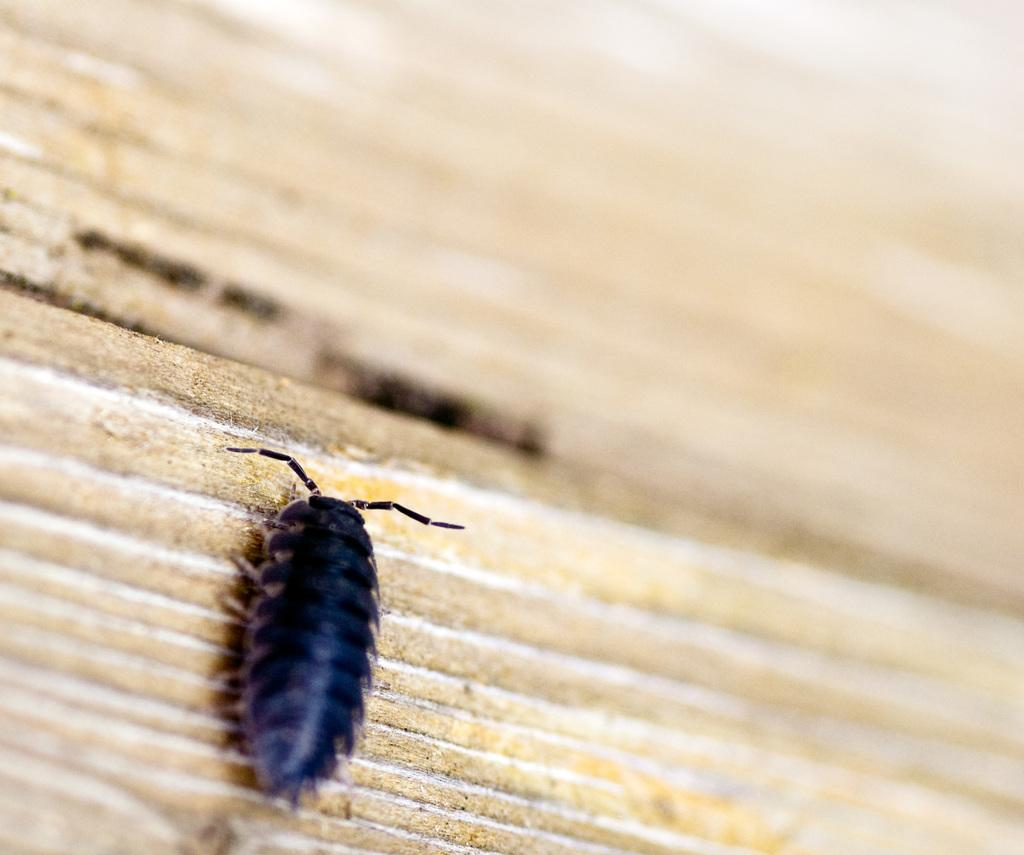What type of creature can be seen in the image? There is an insect in the image. Where is the insect located? The insect is on a path. Can you describe the background of the image? The background of the image is blurred. What type of record can be seen playing in the background of the image? There is no record playing in the background of the image; the background is blurred. What type of horn is visible on the insect in the image? There is no horn present on the insect in the image; it is just an insect. 